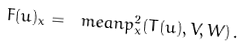<formula> <loc_0><loc_0><loc_500><loc_500>F ( u ) _ { x } = \ m e a n { p _ { x } ^ { 2 } } ( T ( u ) , V , W ) \, .</formula> 